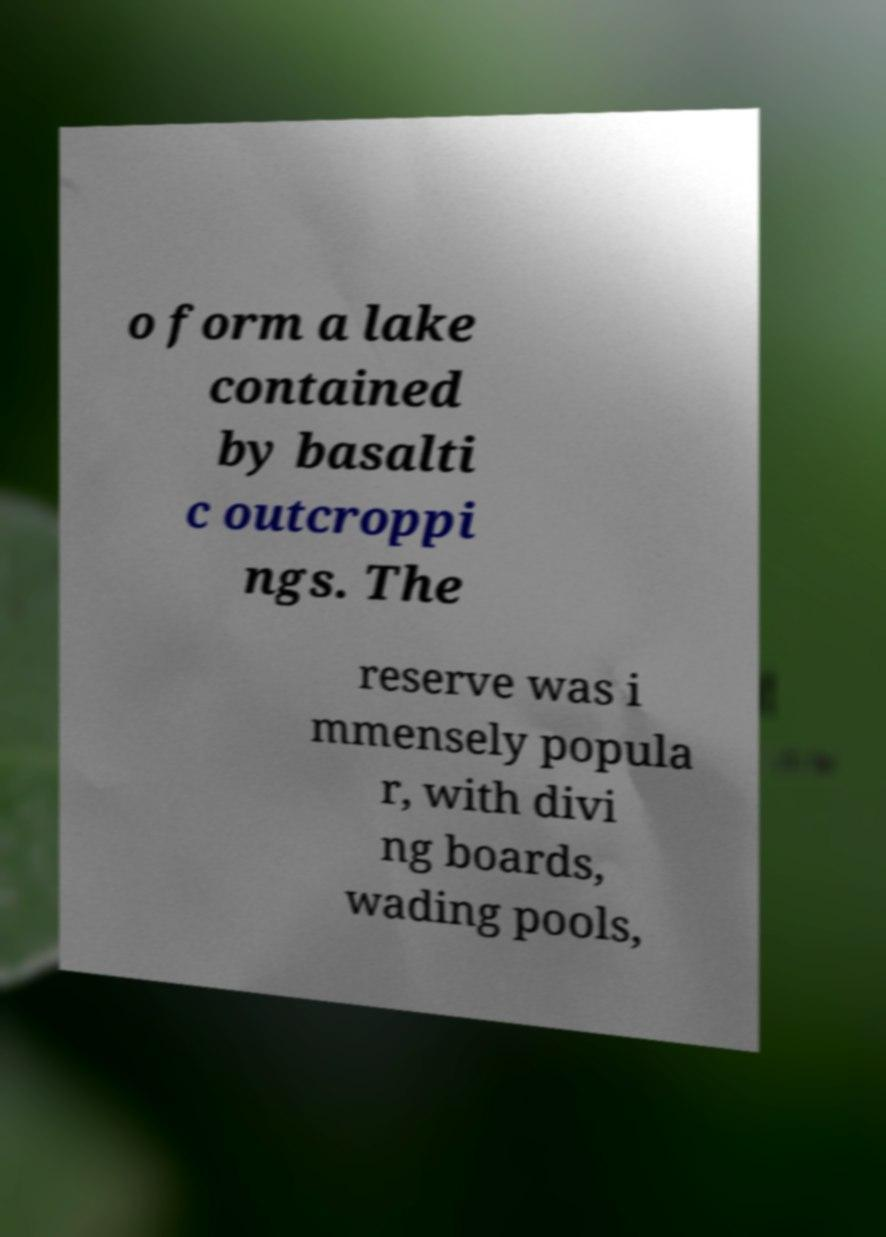Could you extract and type out the text from this image? o form a lake contained by basalti c outcroppi ngs. The reserve was i mmensely popula r, with divi ng boards, wading pools, 